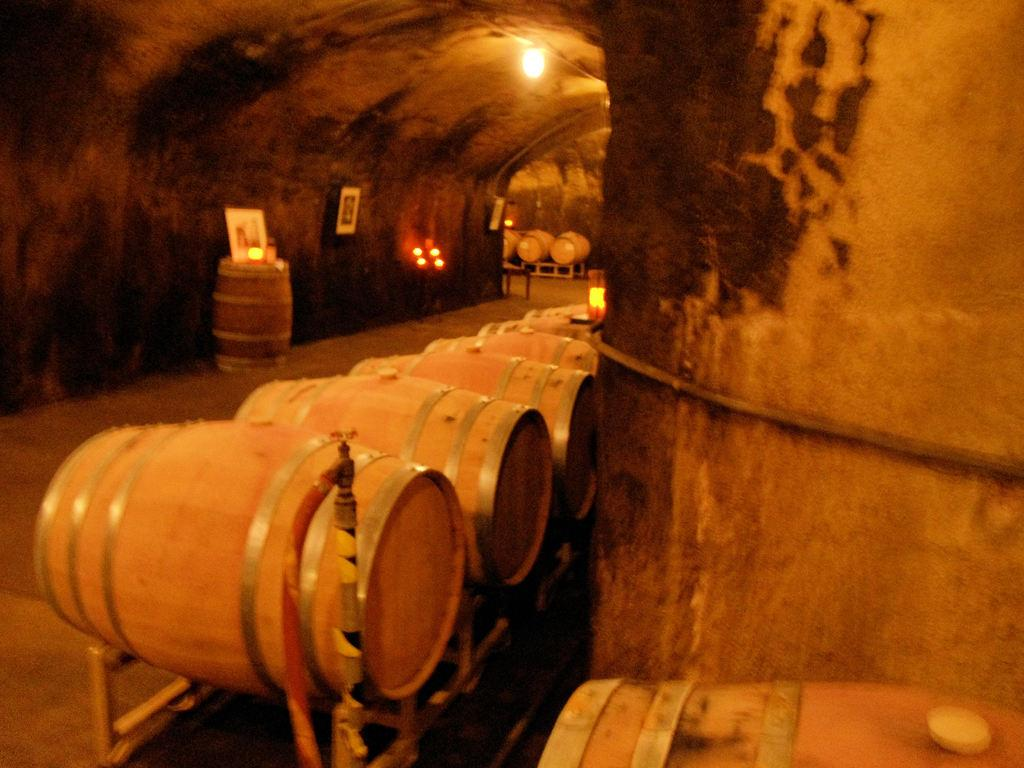What type of objects can be seen in the image? There are barrels in the image. What type of structures are present in the image? There are walls in the image. What type of illumination is visible in the image? There are lights in the image. What type of framing is present in the image? There is a frame in the image. What type of surface is visible in the image? The floor is visible in the image. Can you describe the unspecified objects in the image? Unfortunately, the provided facts do not specify the nature of the unspecified objects in the image. How many cups are being used as slaves to carry the barrels in the image? There are no cups or references to slavery in the image; it features barrels, walls, lights, a frame, and an unspecified floor. What type of bottle is being used to illuminate the room in the image? There are no bottles or references to illumination being provided by bottles in the image; it features lights as the source of illumination. 